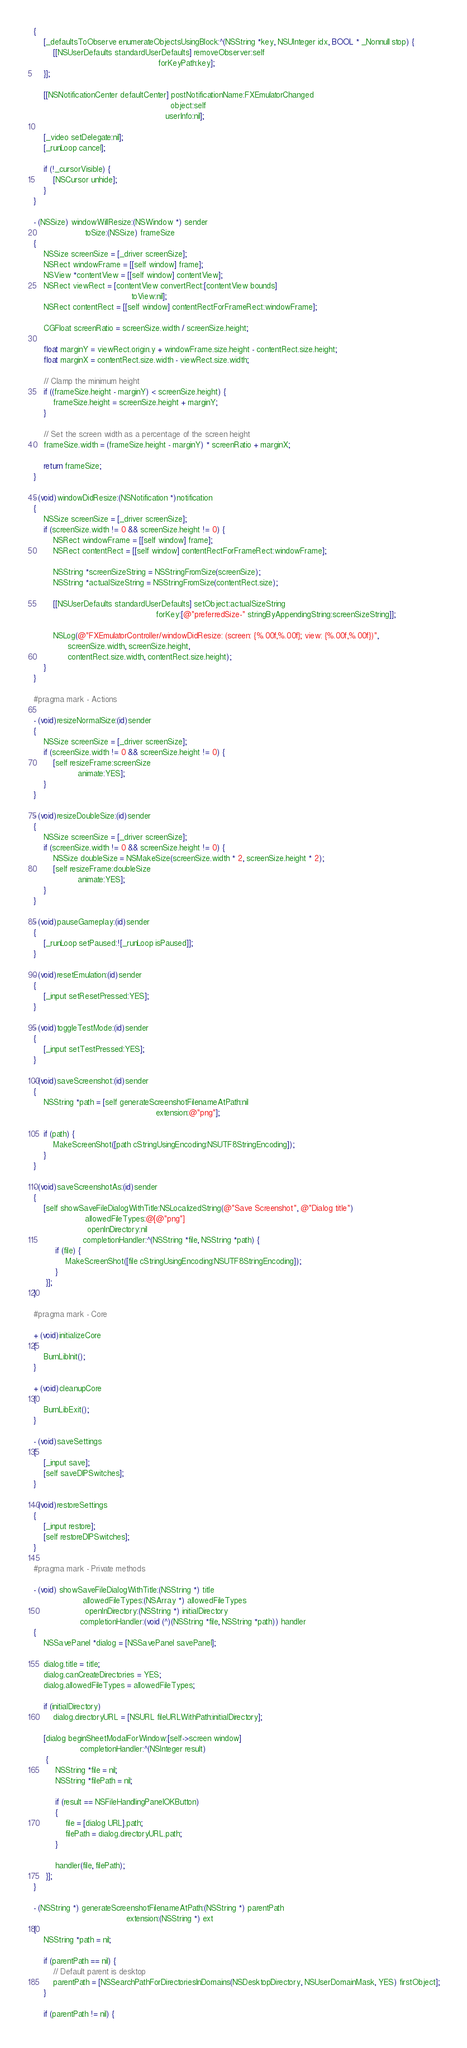<code> <loc_0><loc_0><loc_500><loc_500><_ObjectiveC_>{
	[_defaultsToObserve enumerateObjectsUsingBlock:^(NSString *key, NSUInteger idx, BOOL * _Nonnull stop) {
		[[NSUserDefaults standardUserDefaults] removeObserver:self
												   forKeyPath:key];
	}];

	[[NSNotificationCenter defaultCenter] postNotificationName:FXEmulatorChanged
                                                        object:self
                                                      userInfo:nil];
    
    [_video setDelegate:nil];
    [_runLoop cancel];
	
	if (!_cursorVisible) {
		[NSCursor unhide];
	}
}

- (NSSize) windowWillResize:(NSWindow *) sender
					 toSize:(NSSize) frameSize
{
    NSSize screenSize = [_driver screenSize];
	NSRect windowFrame = [[self window] frame];
	NSView *contentView = [[self window] contentView];
	NSRect viewRect = [contentView convertRect:[contentView bounds]
										toView:nil];
	NSRect contentRect = [[self window] contentRectForFrameRect:windowFrame];
	
	CGFloat screenRatio = screenSize.width / screenSize.height;
	
	float marginY = viewRect.origin.y + windowFrame.size.height - contentRect.size.height;
	float marginX = contentRect.size.width - viewRect.size.width;
	
	// Clamp the minimum height
	if ((frameSize.height - marginY) < screenSize.height) {
		frameSize.height = screenSize.height + marginY;
	}
	
	// Set the screen width as a percentage of the screen height
	frameSize.width = (frameSize.height - marginY) * screenRatio + marginX;
	
    return frameSize;
}

- (void)windowDidResize:(NSNotification *)notification
{
    NSSize screenSize = [_driver screenSize];
    if (screenSize.width != 0 && screenSize.height != 0) {
        NSRect windowFrame = [[self window] frame];
        NSRect contentRect = [[self window] contentRectForFrameRect:windowFrame];
        
        NSString *screenSizeString = NSStringFromSize(screenSize);
        NSString *actualSizeString = NSStringFromSize(contentRect.size);
        
        [[NSUserDefaults standardUserDefaults] setObject:actualSizeString
                                                  forKey:[@"preferredSize-" stringByAppendingString:screenSizeString]];
        
        NSLog(@"FXEmulatorController/windowDidResize: (screen: {%.00f,%.00f}; view: {%.00f,%.00f})",
              screenSize.width, screenSize.height,
              contentRect.size.width, contentRect.size.height);
    }
}

#pragma mark - Actions

- (void)resizeNormalSize:(id)sender
{
    NSSize screenSize = [_driver screenSize];
    if (screenSize.width != 0 && screenSize.height != 0) {
        [self resizeFrame:screenSize
                  animate:YES];
    }
}

- (void)resizeDoubleSize:(id)sender
{
    NSSize screenSize = [_driver screenSize];
    if (screenSize.width != 0 && screenSize.height != 0) {
        NSSize doubleSize = NSMakeSize(screenSize.width * 2, screenSize.height * 2);
        [self resizeFrame:doubleSize
                  animate:YES];
    }
}

- (void)pauseGameplay:(id)sender
{
    [_runLoop setPaused:![_runLoop isPaused]];
}

- (void)resetEmulation:(id)sender
{
	[_input setResetPressed:YES];
}

- (void)toggleTestMode:(id)sender
{
    [_input setTestPressed:YES];
}

- (void)saveScreenshot:(id)sender
{
	NSString *path = [self generateScreenshotFilenameAtPath:nil
												  extension:@"png"];
	
	if (path) {
		MakeScreenShot([path cStringUsingEncoding:NSUTF8StringEncoding]);
	}
}

- (void)saveScreenshotAs:(id)sender
{
	[self showSaveFileDialogWithTitle:NSLocalizedString(@"Save Screenshot", @"Dialog title")
					 allowedFileTypes:@[@"png"]
					  openInDirectory:nil
					completionHandler:^(NSString *file, NSString *path) {
		 if (file) {
			 MakeScreenShot([file cStringUsingEncoding:NSUTF8StringEncoding]);
		 }
	 }];
}

#pragma mark - Core

+ (void)initializeCore
{
    BurnLibInit();
}

+ (void)cleanupCore
{
    BurnLibExit();
}

- (void)saveSettings
{
	[_input save];
	[self saveDIPSwitches];
}

- (void)restoreSettings
{
    [_input restore];
	[self restoreDIPSwitches];
}

#pragma mark - Private methods

- (void) showSaveFileDialogWithTitle:(NSString *) title
					allowedFileTypes:(NSArray *) allowedFileTypes
					 openInDirectory:(NSString *) initialDirectory
				   completionHandler:(void (^)(NSString *file, NSString *path)) handler
{
	NSSavePanel *dialog = [NSSavePanel savePanel];
	
	dialog.title = title;
	dialog.canCreateDirectories = YES;
	dialog.allowedFileTypes = allowedFileTypes;
	
	if (initialDirectory)
		dialog.directoryURL = [NSURL fileURLWithPath:initialDirectory];
	
	[dialog beginSheetModalForWindow:[self->screen window]
				   completionHandler:^(NSInteger result)
	 {
		 NSString *file = nil;
		 NSString *filePath = nil;
		 
		 if (result == NSFileHandlingPanelOKButton)
		 {
			 file = [dialog URL].path;
			 filePath = dialog.directoryURL.path;
		 }
		 
		 handler(file, filePath);
	 }];
}

- (NSString *) generateScreenshotFilenameAtPath:(NSString *) parentPath
									  extension:(NSString *) ext
{
	NSString *path = nil;
	
	if (parentPath == nil) {
		// Default parent is desktop
		parentPath = [NSSearchPathForDirectoriesInDomains(NSDesktopDirectory, NSUserDomainMask, YES) firstObject];
	}
	
	if (parentPath != nil) {</code> 